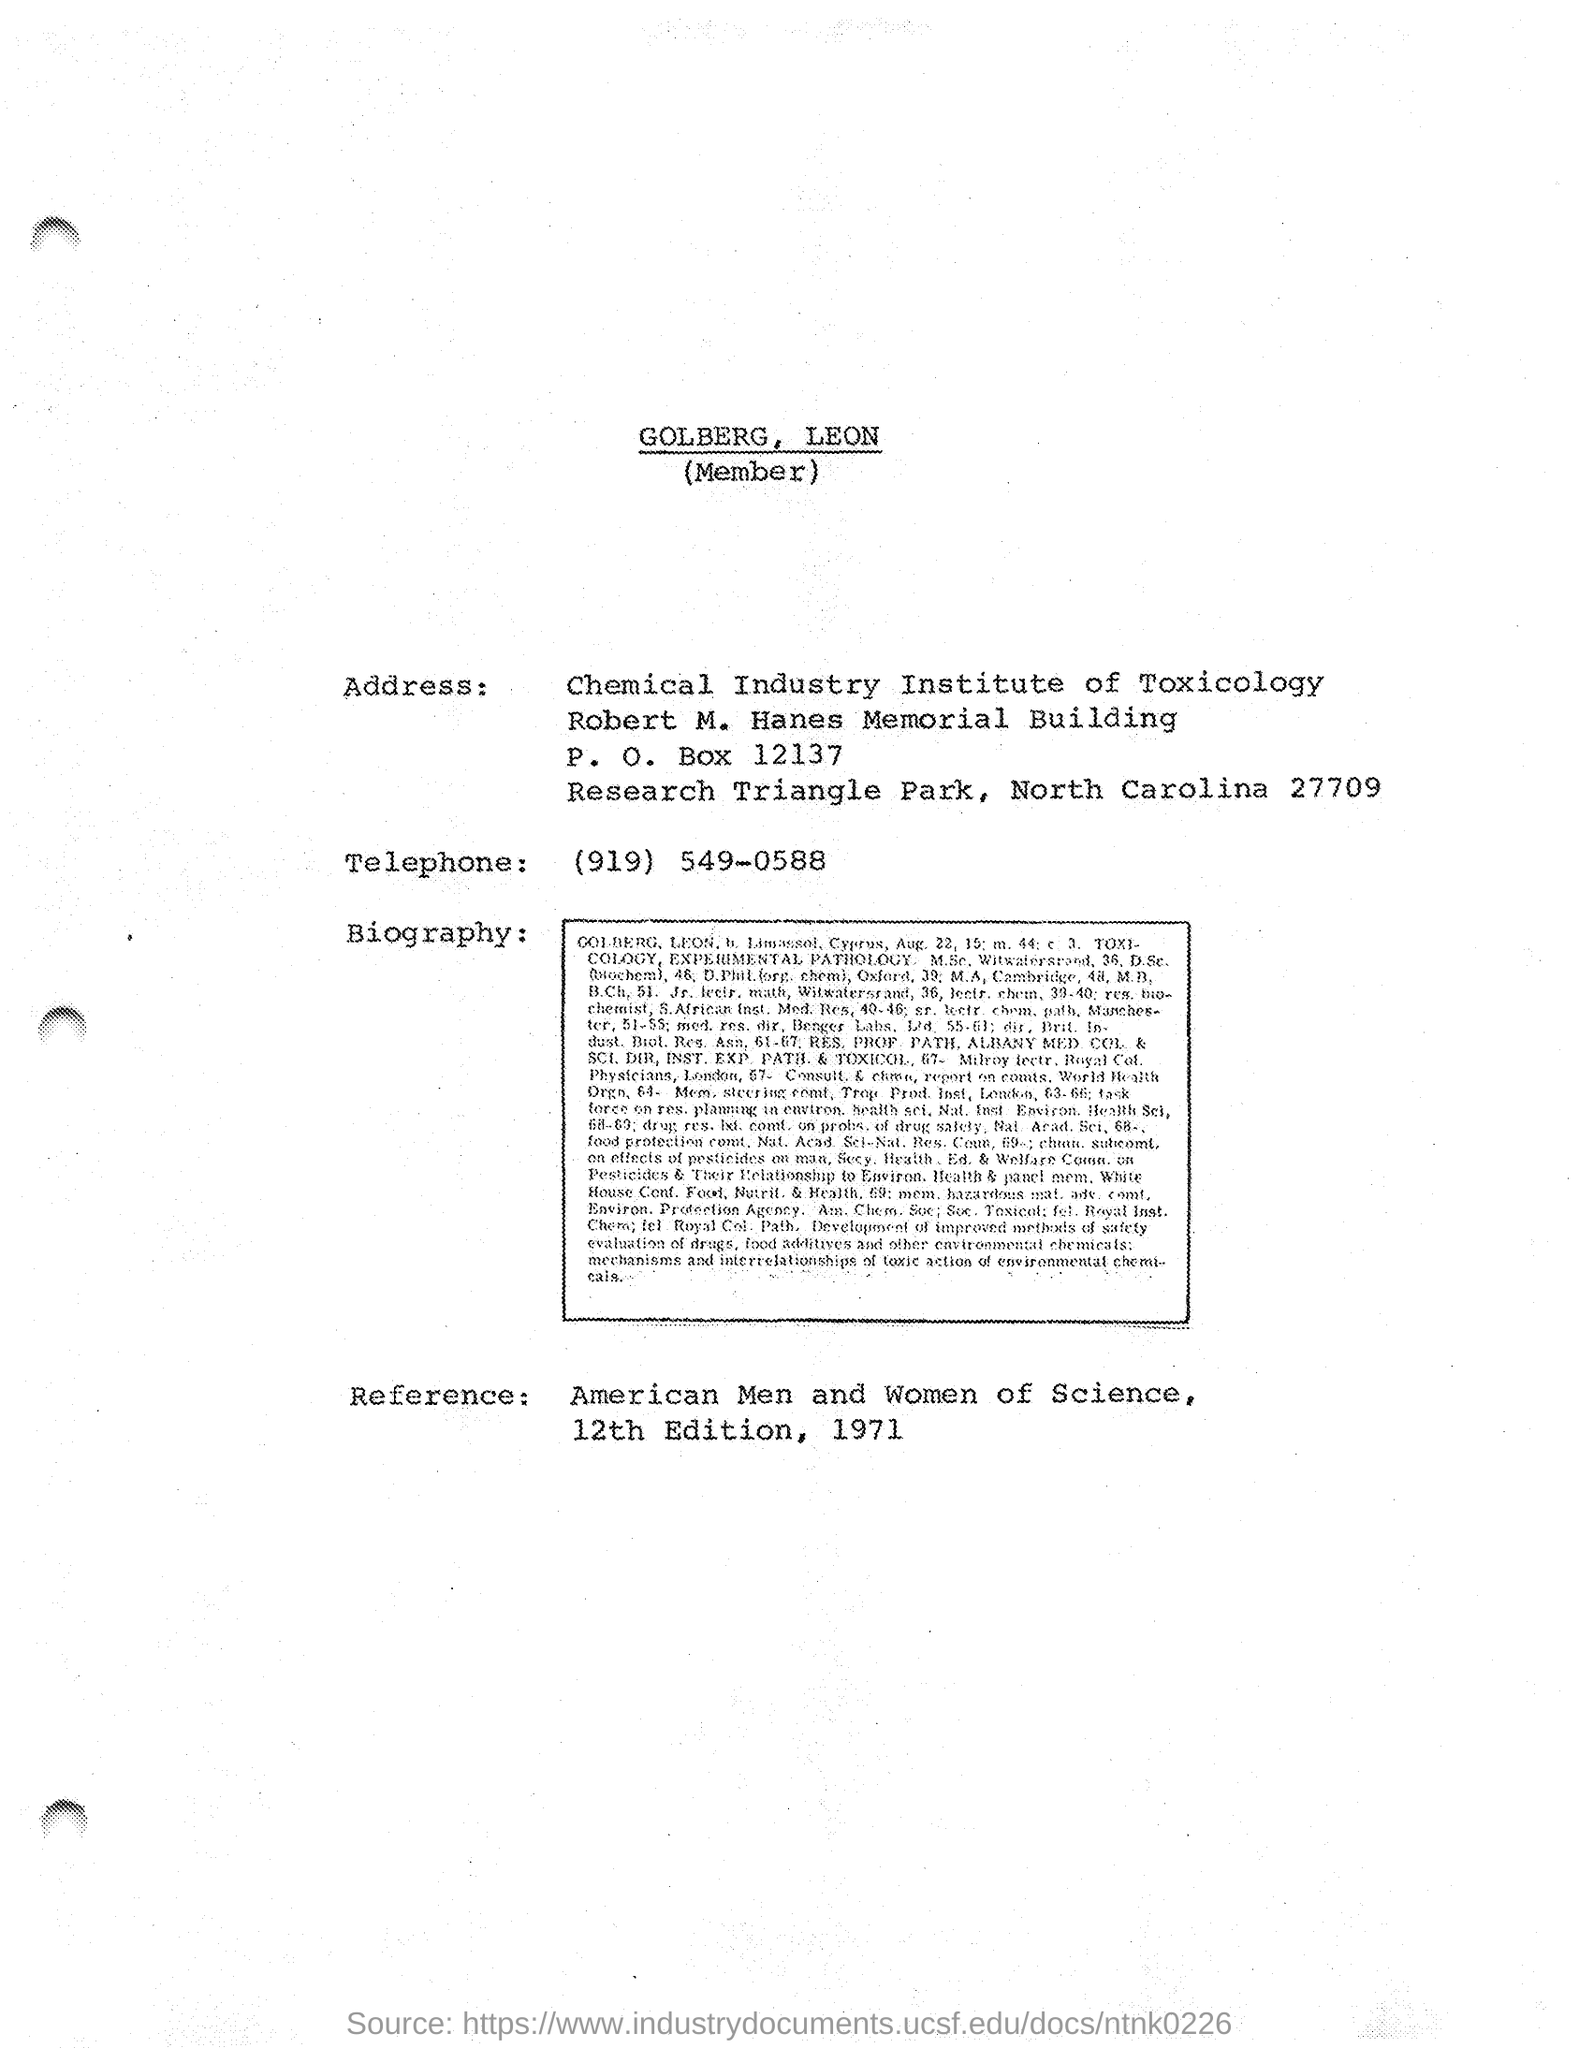Where is the chemical industry institute of Toxicology located?
Make the answer very short. North Carolina. 